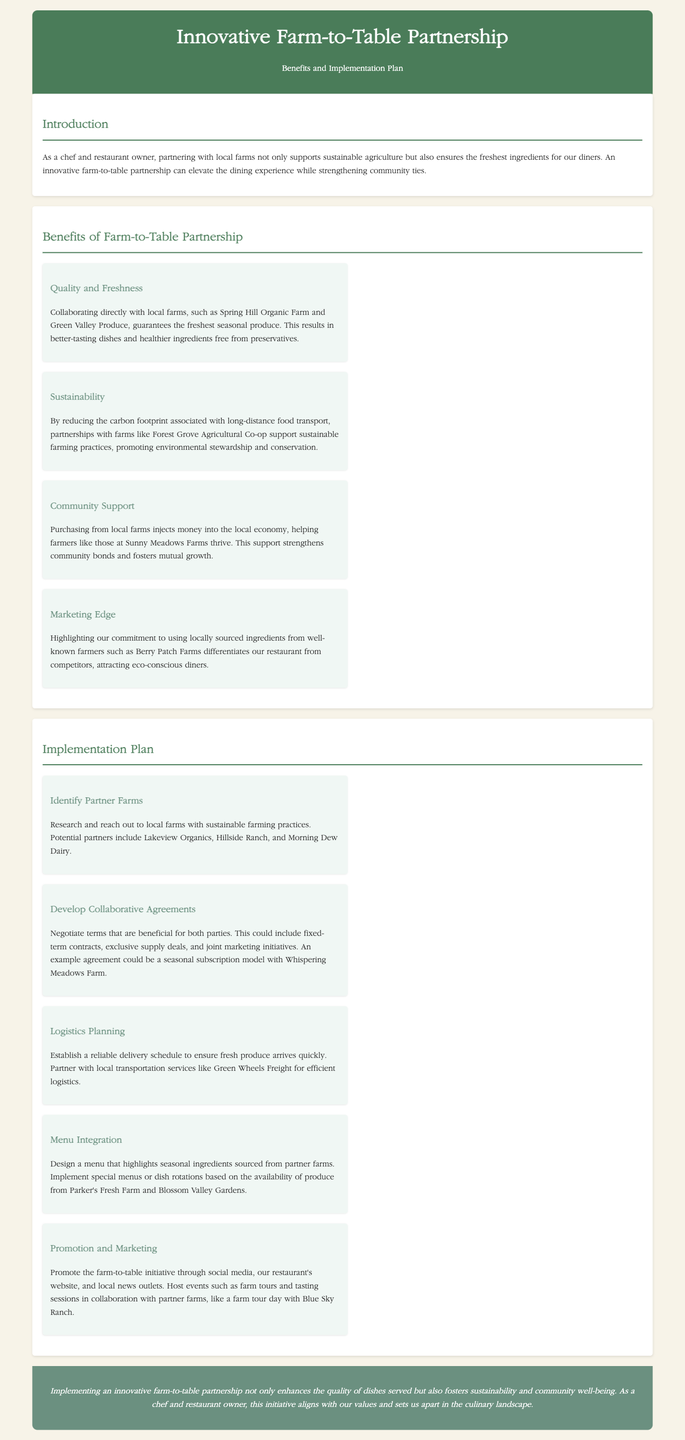What is the title of the proposal? The title of the proposal is stated at the top of the document.
Answer: Innovative Farm-to-Table Partnership Which farm is mentioned as a potential partner for a seasonal subscription model? The document specifies an example agreement that involves one specific farm.
Answer: Whispering Meadows Farm How does a farm-to-table partnership contribute to sustainability? The proposal states a direct benefit of these partnerships regarding environmental issues.
Answer: Reducing carbon footprint What is one way to promote the farm-to-table initiative? The document provides various methods for marketing, including specific channels for promotion.
Answer: Host events How many benefits of farm-to-table partnerships are listed in the document? The benefits are clearly outlined in a section of the proposal, consisting of various benefits.
Answer: Four What is the primary objective of the proposal? The introduction provides a clear purpose for the farm-to-table partnership initiative.
Answer: Enhancing dining experience Which farm is mentioned for efficient logistics planning? The proposal mentions a specific local transportation service to ensure fresh produce delivery.
Answer: Green Wheels Freight Name one of the community benefits highlighted in the proposal. The document discusses community support as an essential advantage of partnering with local farms.
Answer: Strengthening community bonds 